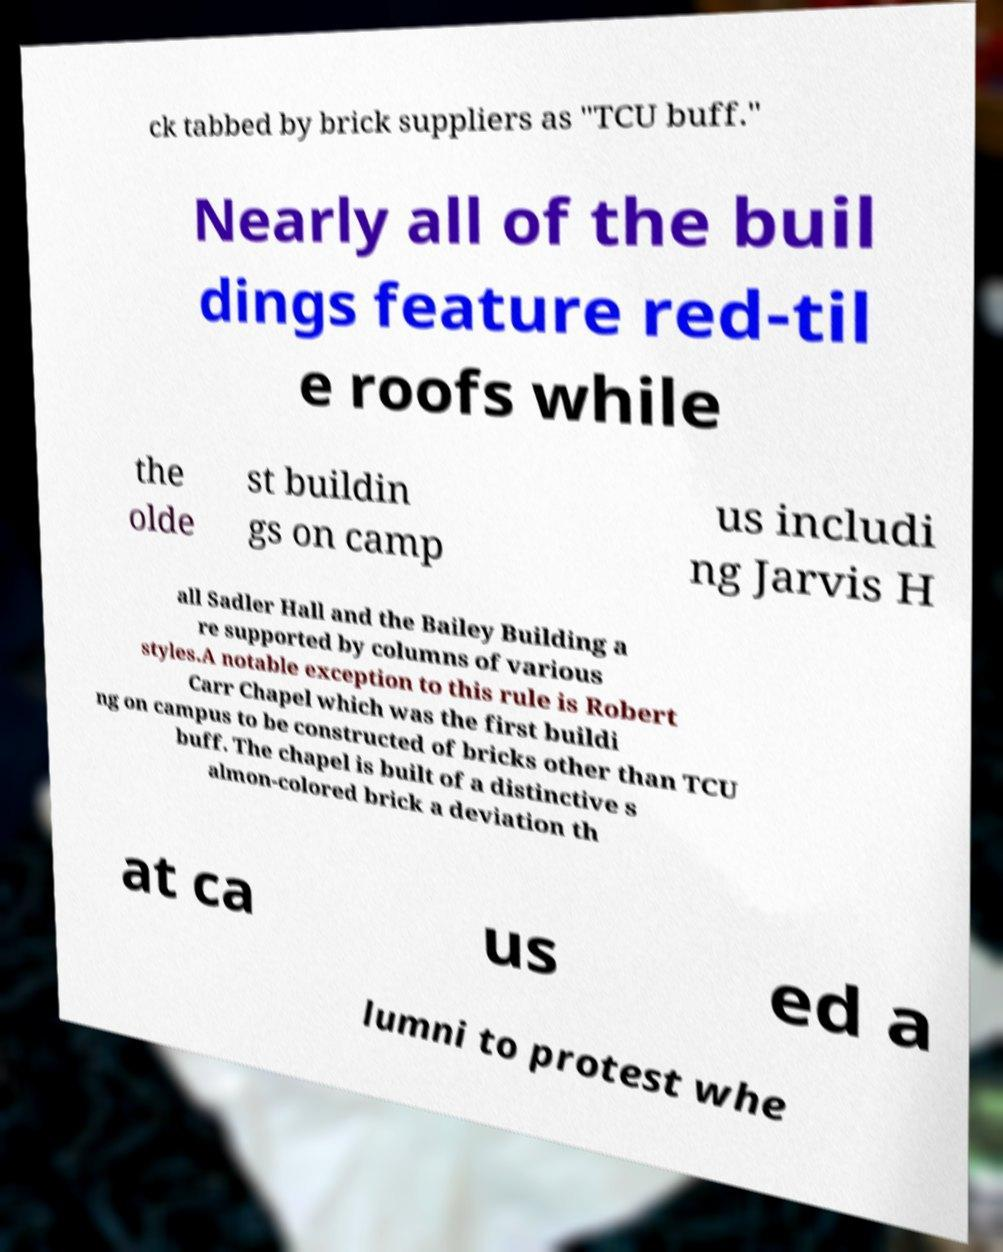Could you extract and type out the text from this image? ck tabbed by brick suppliers as "TCU buff." Nearly all of the buil dings feature red-til e roofs while the olde st buildin gs on camp us includi ng Jarvis H all Sadler Hall and the Bailey Building a re supported by columns of various styles.A notable exception to this rule is Robert Carr Chapel which was the first buildi ng on campus to be constructed of bricks other than TCU buff. The chapel is built of a distinctive s almon-colored brick a deviation th at ca us ed a lumni to protest whe 